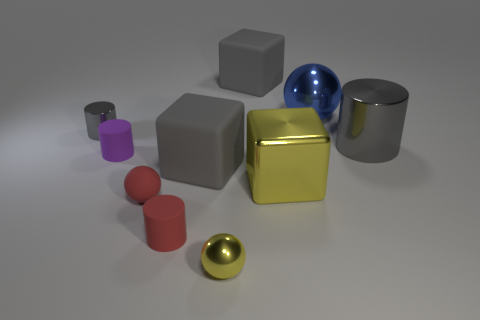Subtract all gray blocks. Subtract all yellow cylinders. How many blocks are left? 1 Subtract all balls. How many objects are left? 7 Subtract all cylinders. Subtract all gray objects. How many objects are left? 2 Add 1 tiny red rubber things. How many tiny red rubber things are left? 3 Add 6 big blue objects. How many big blue objects exist? 7 Subtract 0 brown spheres. How many objects are left? 10 